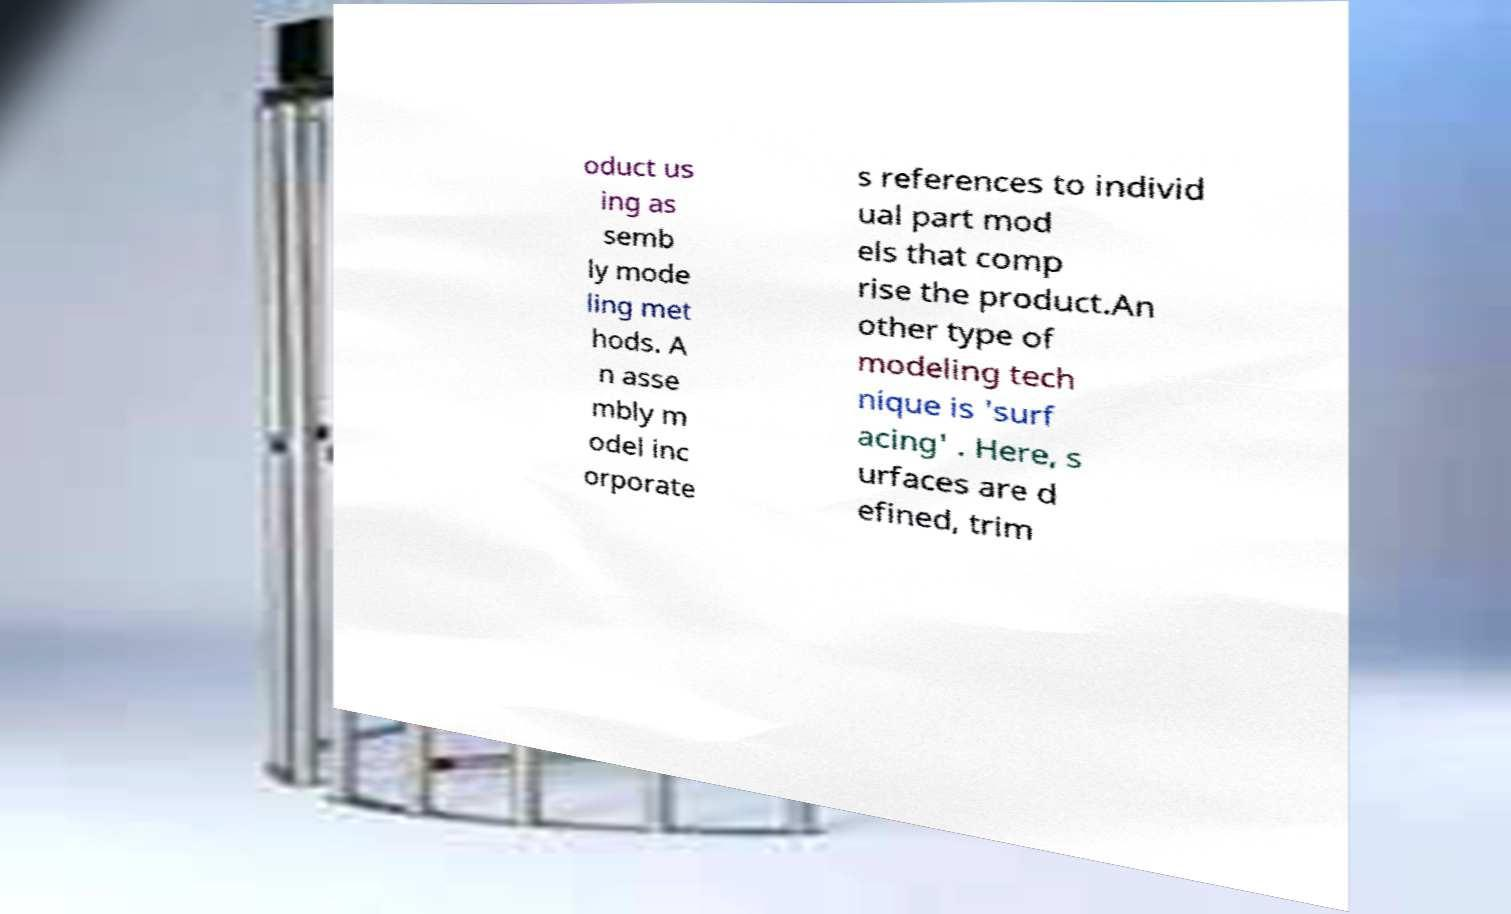For documentation purposes, I need the text within this image transcribed. Could you provide that? oduct us ing as semb ly mode ling met hods. A n asse mbly m odel inc orporate s references to individ ual part mod els that comp rise the product.An other type of modeling tech nique is 'surf acing' . Here, s urfaces are d efined, trim 